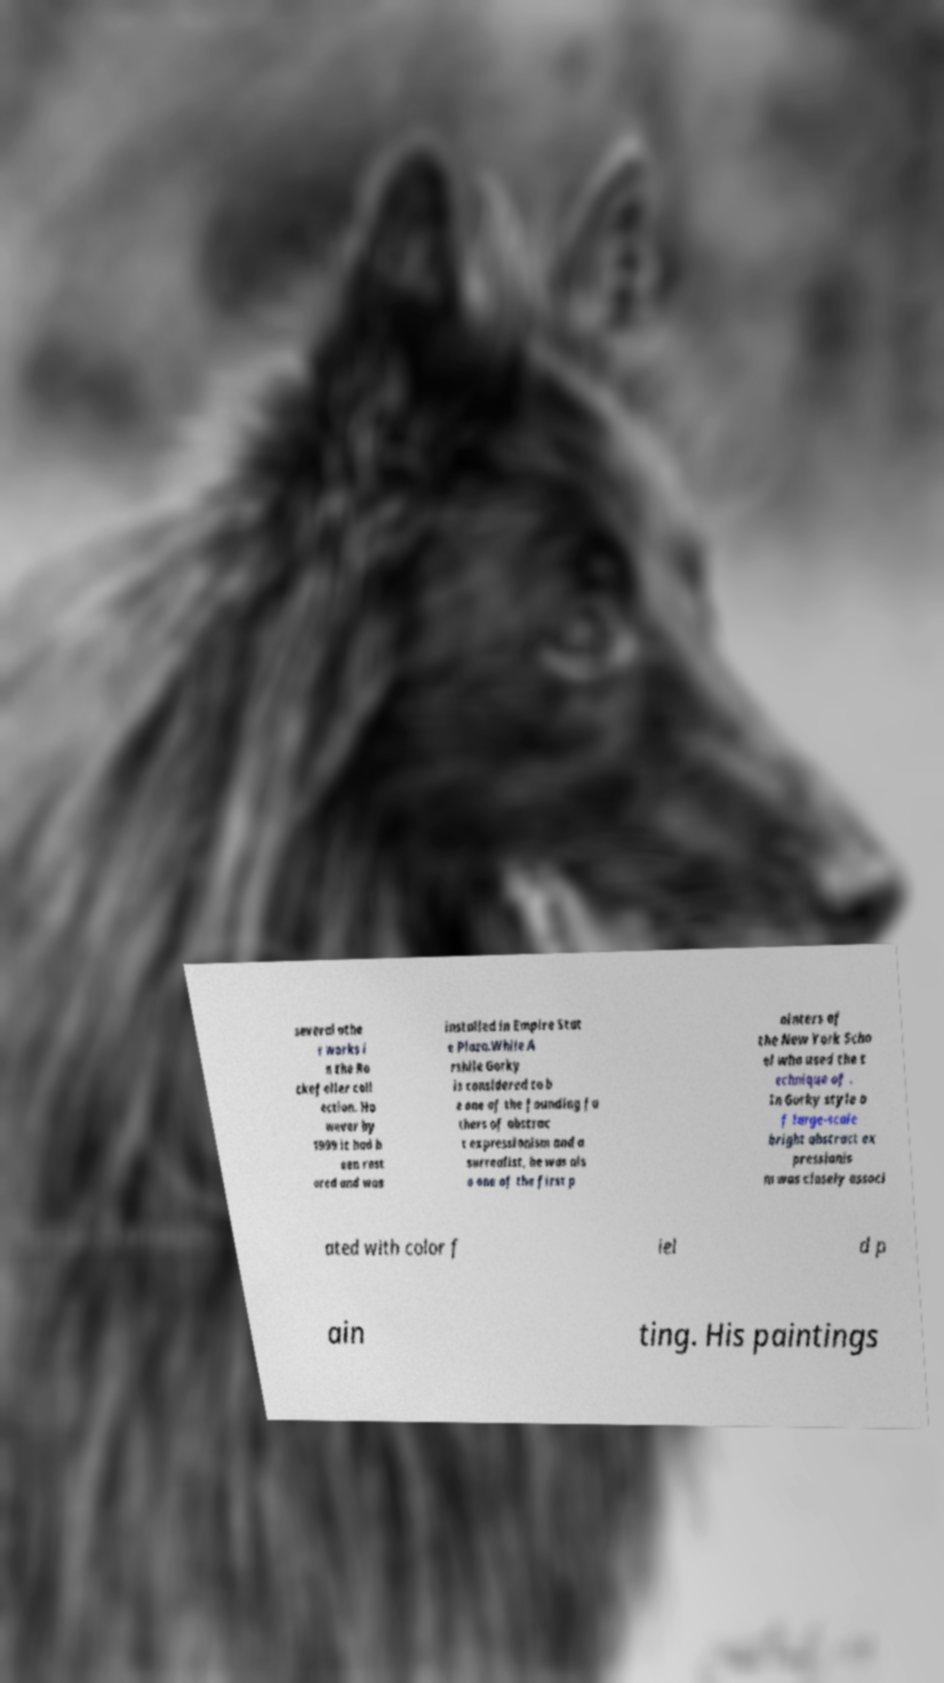Could you assist in decoding the text presented in this image and type it out clearly? several othe r works i n the Ro ckefeller coll ection. Ho wever by 1999 it had b een rest ored and was installed in Empire Stat e Plaza.While A rshile Gorky is considered to b e one of the founding fa thers of abstrac t expressionism and a surrealist, he was als o one of the first p ainters of the New York Scho ol who used the t echnique of . In Gorky style o f large-scale bright abstract ex pressionis m was closely associ ated with color f iel d p ain ting. His paintings 